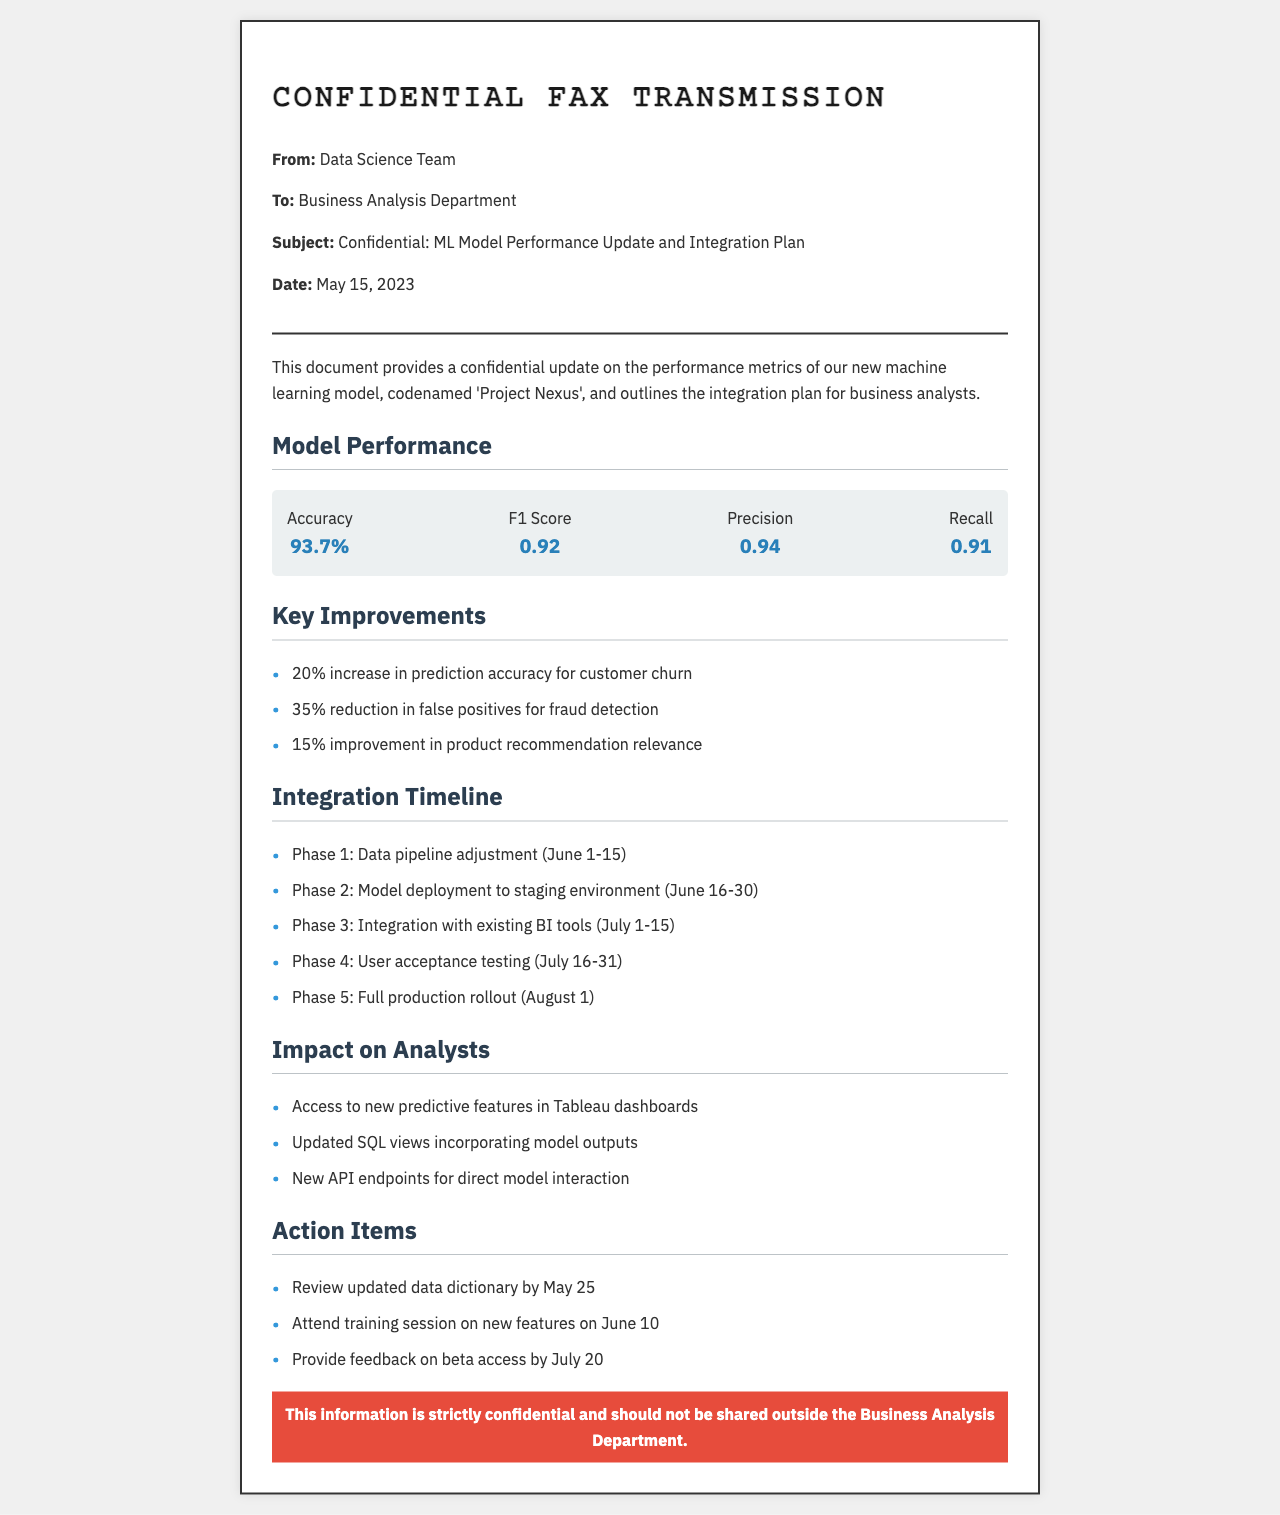What is the subject of the fax? The subject is stated clearly in the document as "Confidential: ML Model Performance Update and Integration Plan.”
Answer: Confidential: ML Model Performance Update and Integration Plan What is the accuracy of the model? The accuracy metric is shown in the performance metrics section, which is 93.7%.
Answer: 93.7% What is the F1 Score of the model? The F1 Score is specified in the performance metrics and is valued at 0.92.
Answer: 0.92 What is the percentage reduction in false positives for fraud detection? The document states a 35% reduction in false positives for fraud detection under the key improvements section.
Answer: 35% What is the date range for the first phase of the integration timeline? The integration timeline specifies the date range for Phase 1 as June 1-15.
Answer: June 1-15 What new feature will analysts access in Tableau dashboards? The document mentions access to new predictive features as a key impact on analysts.
Answer: Predictive features How many action items are listed in the document? The document lists three action items under the action items section.
Answer: Three What is the confidentiality status of this document? The document contains a specific statement about confidentiality at its conclusion, emphasizing that the information is strictly confidential.
Answer: Strictly confidential Which department is the fax sent to? The target department for this fax is specified in the header as the Business Analysis Department.
Answer: Business Analysis Department 